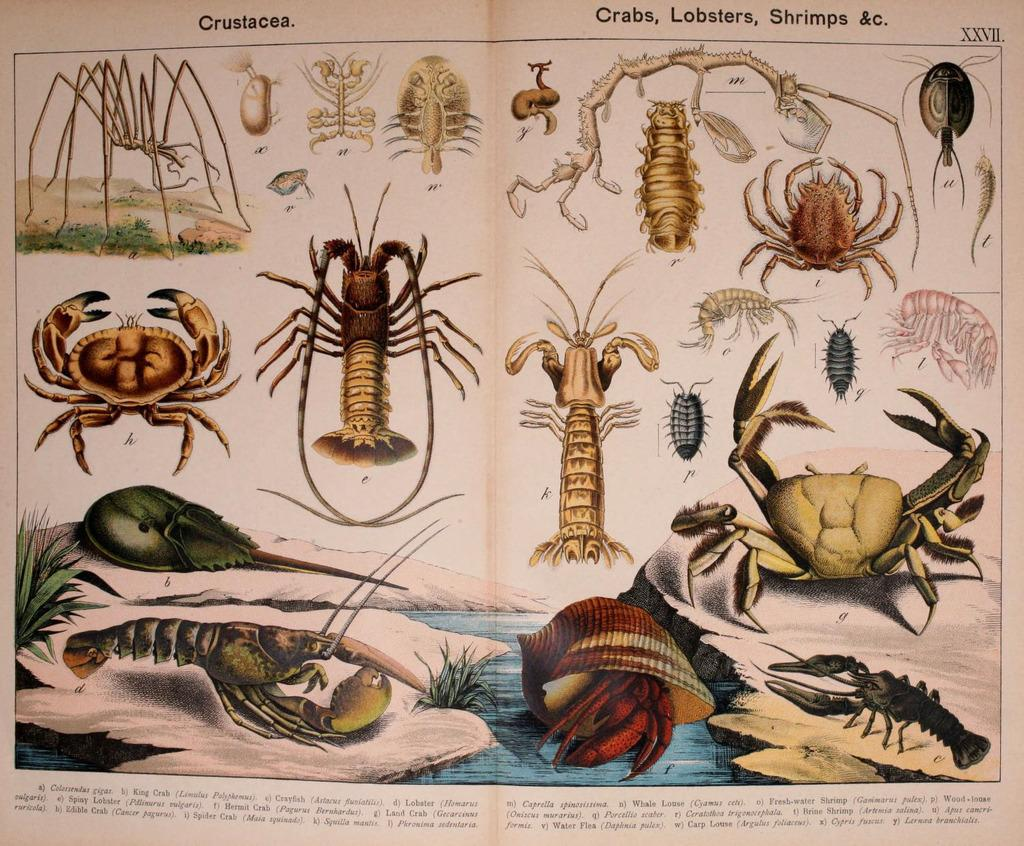What is the main subject of the paper in the image? The main subject of the paper in the image is a collection of images, including crabs, prawns, spiders, shells, and insects. Can you describe the content of the images on the paper? The images on the paper include crabs, prawns, spiders, shells, and insects. Is there any text present on the paper? Yes, there is text on the paper. What type of leather can be seen on the geese in the image? There are no geese present in the image, and therefore no leather can be observed. What is the curve of the insect's wings in the image? There are no insect wings visible in the image, as the insects are depicted in a non-flying state. 